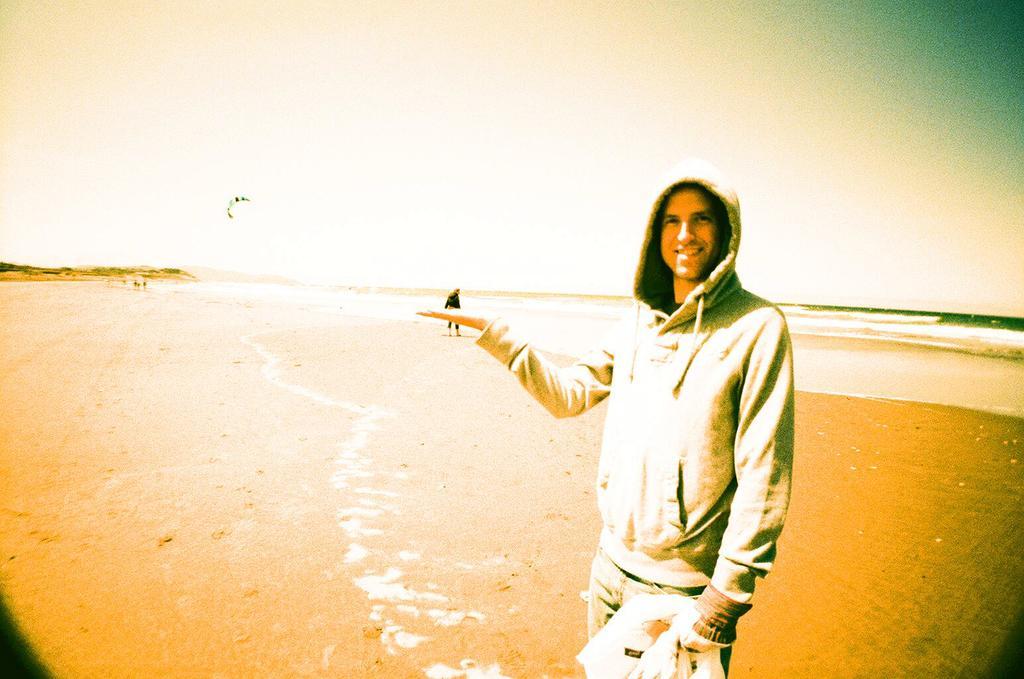Could you give a brief overview of what you see in this image? This image consists of a man standing near the beach. At the bottom, there is sand. In the background, there are waves in the water. At the top, there is a sky. 